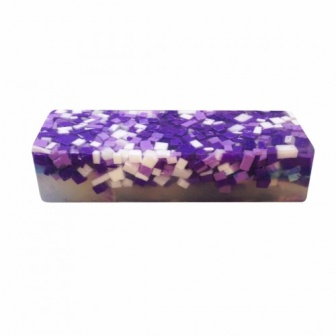What kind of experience would this soap provide if it were used in a luxurious spa? In a luxurious spa setting, this soap would contribute to an unforgettable pampering experience. The varied hues of purple and white would complement the spa's serene ambiance, enhancing the aesthetic pleasure. The soap could be incorporated into various treatments, from a tranquil handwashing ritual to a full-body massage, where its soothing properties would be fully realized. The spa could emphasize the soap's artisanal design, marketing it as a signature product that adds both beauty and relaxation to the overall spa experience. 